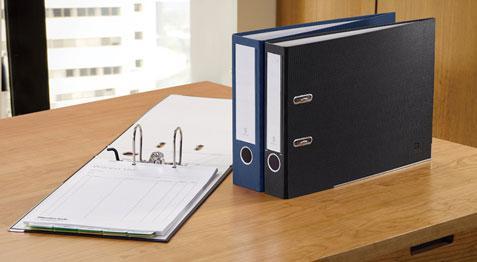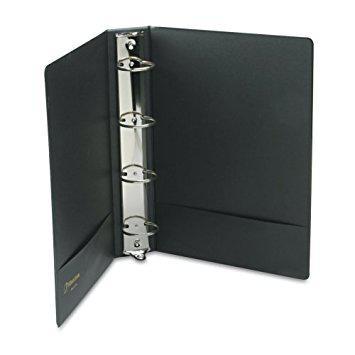The first image is the image on the left, the second image is the image on the right. Assess this claim about the two images: "The binder in the image on the right is open to show white pages.". Correct or not? Answer yes or no. No. The first image is the image on the left, the second image is the image on the right. Examine the images to the left and right. Is the description "One image shows a single upright black binder, and the other image shows a paper-filled open binder lying by at least one upright closed binder." accurate? Answer yes or no. Yes. 